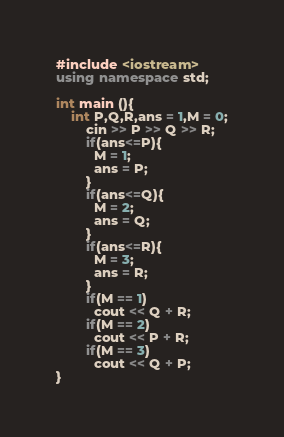<code> <loc_0><loc_0><loc_500><loc_500><_C++_>#include <iostream>
using namespace std;
 
int main (){
	int P,Q,R,ans = 1,M = 0;
    	cin >> P >> Q >> R;
        if(ans<=P){
          M = 1;
          ans = P;
        }
  		if(ans<=Q){
          M = 2;
          ans = Q;
        }
  		if(ans<=R){
          M = 3;
          ans = R;
        }
  		if(M == 1)
          cout << Q + R;
  		if(M == 2)
          cout << P + R;
  		if(M == 3)
          cout << Q + P;
}</code> 